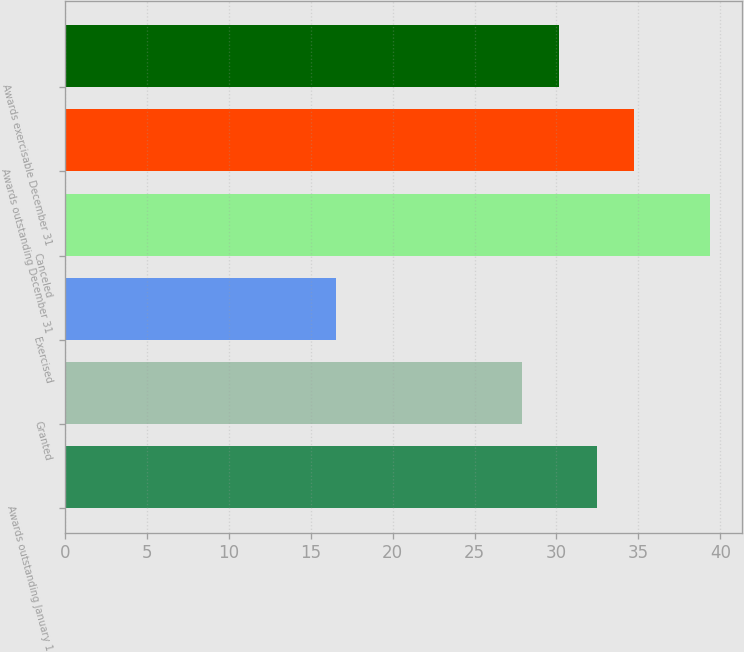Convert chart. <chart><loc_0><loc_0><loc_500><loc_500><bar_chart><fcel>Awards outstanding January 1<fcel>Granted<fcel>Exercised<fcel>Canceled<fcel>Awards outstanding December 31<fcel>Awards exercisable December 31<nl><fcel>32.46<fcel>27.9<fcel>16.55<fcel>39.34<fcel>34.74<fcel>30.18<nl></chart> 